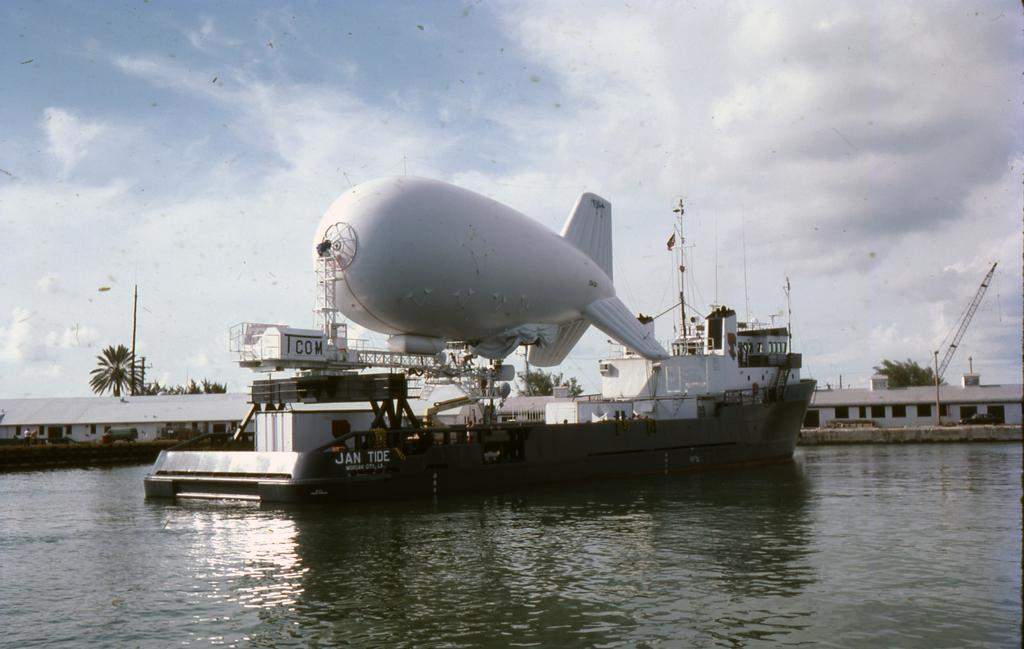What type of vehicle is in the water in the image? There is a war ship in the water in the image. What is visible at the top of the image? The sky is visible at the top of the image. What can be seen in the background of the image? There are sheds and buildings in the background of the image. What is flying above the ship in the image? There is a small airplane above the ship in the image. What time of day is it based on the hour shown in the image? There is no hour or time of day indicated in the image. What type of match is being played in the image? There is no match or any sports activity present in the image. 